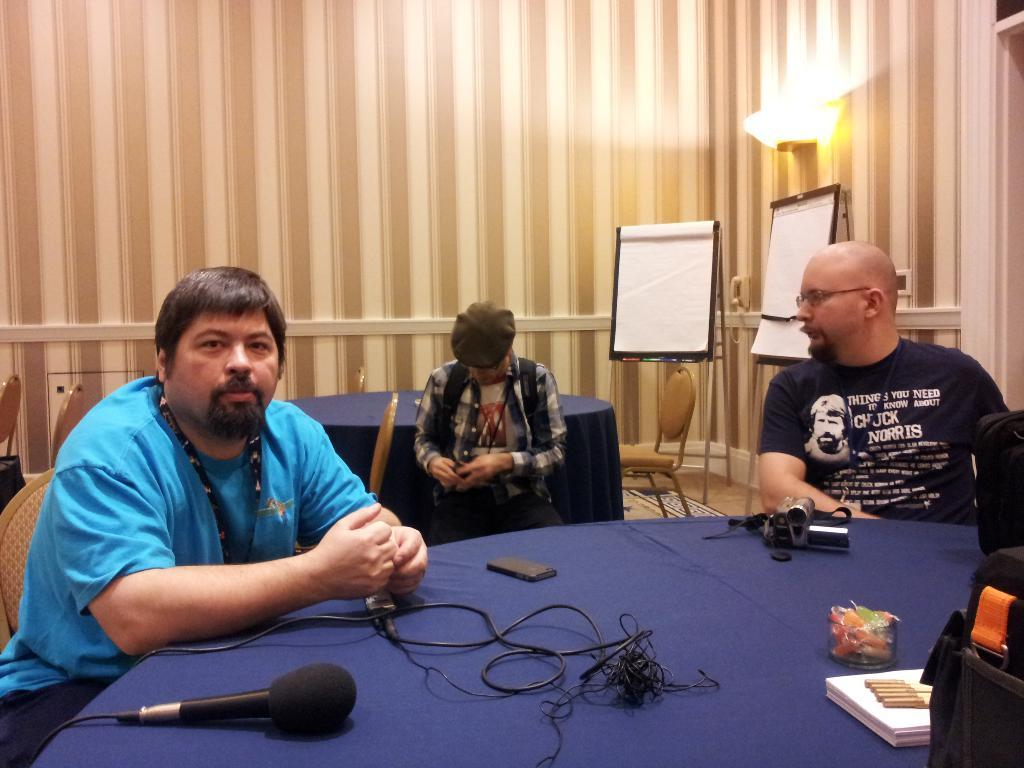How many people are present in the image? There are three people in the image. What are the people doing in the image? The people are sitting on a blue table. What can be seen in the background of the image? There is a white notice board and a designed wall in the background. What type of dinosaurs can be seen roaming in the background of the image? There are no dinosaurs present in the image; the background features a white notice board and a designed wall. 